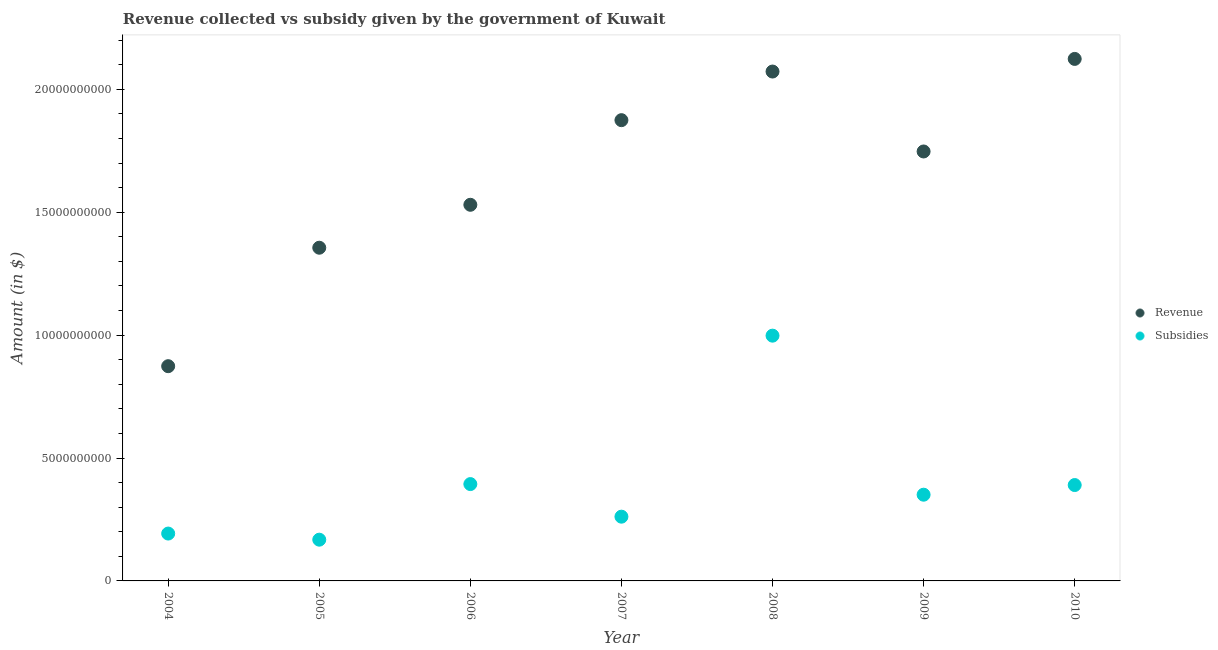What is the amount of subsidies given in 2004?
Provide a succinct answer. 1.93e+09. Across all years, what is the maximum amount of subsidies given?
Provide a short and direct response. 9.98e+09. Across all years, what is the minimum amount of subsidies given?
Your answer should be compact. 1.68e+09. In which year was the amount of revenue collected minimum?
Your response must be concise. 2004. What is the total amount of revenue collected in the graph?
Offer a very short reply. 1.16e+11. What is the difference between the amount of revenue collected in 2004 and that in 2005?
Give a very brief answer. -4.82e+09. What is the difference between the amount of revenue collected in 2007 and the amount of subsidies given in 2008?
Offer a very short reply. 8.77e+09. What is the average amount of revenue collected per year?
Provide a short and direct response. 1.65e+1. In the year 2006, what is the difference between the amount of revenue collected and amount of subsidies given?
Give a very brief answer. 1.14e+1. In how many years, is the amount of revenue collected greater than 7000000000 $?
Offer a very short reply. 7. What is the ratio of the amount of revenue collected in 2005 to that in 2008?
Offer a very short reply. 0.65. Is the amount of subsidies given in 2006 less than that in 2008?
Provide a succinct answer. Yes. What is the difference between the highest and the second highest amount of subsidies given?
Make the answer very short. 6.04e+09. What is the difference between the highest and the lowest amount of subsidies given?
Ensure brevity in your answer.  8.30e+09. In how many years, is the amount of subsidies given greater than the average amount of subsidies given taken over all years?
Provide a short and direct response. 2. How many dotlines are there?
Ensure brevity in your answer.  2. How many years are there in the graph?
Keep it short and to the point. 7. Does the graph contain any zero values?
Make the answer very short. No. How many legend labels are there?
Provide a succinct answer. 2. What is the title of the graph?
Keep it short and to the point. Revenue collected vs subsidy given by the government of Kuwait. What is the label or title of the X-axis?
Keep it short and to the point. Year. What is the label or title of the Y-axis?
Make the answer very short. Amount (in $). What is the Amount (in $) of Revenue in 2004?
Ensure brevity in your answer.  8.74e+09. What is the Amount (in $) of Subsidies in 2004?
Your response must be concise. 1.93e+09. What is the Amount (in $) of Revenue in 2005?
Make the answer very short. 1.36e+1. What is the Amount (in $) in Subsidies in 2005?
Offer a terse response. 1.68e+09. What is the Amount (in $) of Revenue in 2006?
Provide a succinct answer. 1.53e+1. What is the Amount (in $) of Subsidies in 2006?
Give a very brief answer. 3.94e+09. What is the Amount (in $) of Revenue in 2007?
Provide a succinct answer. 1.87e+1. What is the Amount (in $) in Subsidies in 2007?
Your answer should be very brief. 2.61e+09. What is the Amount (in $) in Revenue in 2008?
Your answer should be very brief. 2.07e+1. What is the Amount (in $) in Subsidies in 2008?
Offer a terse response. 9.98e+09. What is the Amount (in $) in Revenue in 2009?
Make the answer very short. 1.75e+1. What is the Amount (in $) of Subsidies in 2009?
Your response must be concise. 3.51e+09. What is the Amount (in $) in Revenue in 2010?
Provide a succinct answer. 2.12e+1. What is the Amount (in $) in Subsidies in 2010?
Offer a very short reply. 3.90e+09. Across all years, what is the maximum Amount (in $) in Revenue?
Offer a very short reply. 2.12e+1. Across all years, what is the maximum Amount (in $) in Subsidies?
Offer a terse response. 9.98e+09. Across all years, what is the minimum Amount (in $) in Revenue?
Give a very brief answer. 8.74e+09. Across all years, what is the minimum Amount (in $) in Subsidies?
Keep it short and to the point. 1.68e+09. What is the total Amount (in $) in Revenue in the graph?
Ensure brevity in your answer.  1.16e+11. What is the total Amount (in $) of Subsidies in the graph?
Give a very brief answer. 2.75e+1. What is the difference between the Amount (in $) of Revenue in 2004 and that in 2005?
Make the answer very short. -4.82e+09. What is the difference between the Amount (in $) in Subsidies in 2004 and that in 2005?
Make the answer very short. 2.49e+08. What is the difference between the Amount (in $) of Revenue in 2004 and that in 2006?
Give a very brief answer. -6.57e+09. What is the difference between the Amount (in $) in Subsidies in 2004 and that in 2006?
Your answer should be compact. -2.01e+09. What is the difference between the Amount (in $) of Revenue in 2004 and that in 2007?
Give a very brief answer. -1.00e+1. What is the difference between the Amount (in $) in Subsidies in 2004 and that in 2007?
Ensure brevity in your answer.  -6.87e+08. What is the difference between the Amount (in $) in Revenue in 2004 and that in 2008?
Provide a succinct answer. -1.20e+1. What is the difference between the Amount (in $) of Subsidies in 2004 and that in 2008?
Provide a succinct answer. -8.05e+09. What is the difference between the Amount (in $) in Revenue in 2004 and that in 2009?
Keep it short and to the point. -8.74e+09. What is the difference between the Amount (in $) of Subsidies in 2004 and that in 2009?
Ensure brevity in your answer.  -1.58e+09. What is the difference between the Amount (in $) in Revenue in 2004 and that in 2010?
Ensure brevity in your answer.  -1.25e+1. What is the difference between the Amount (in $) in Subsidies in 2004 and that in 2010?
Offer a very short reply. -1.97e+09. What is the difference between the Amount (in $) in Revenue in 2005 and that in 2006?
Provide a succinct answer. -1.75e+09. What is the difference between the Amount (in $) in Subsidies in 2005 and that in 2006?
Keep it short and to the point. -2.26e+09. What is the difference between the Amount (in $) in Revenue in 2005 and that in 2007?
Ensure brevity in your answer.  -5.19e+09. What is the difference between the Amount (in $) in Subsidies in 2005 and that in 2007?
Provide a succinct answer. -9.36e+08. What is the difference between the Amount (in $) of Revenue in 2005 and that in 2008?
Make the answer very short. -7.17e+09. What is the difference between the Amount (in $) in Subsidies in 2005 and that in 2008?
Give a very brief answer. -8.30e+09. What is the difference between the Amount (in $) in Revenue in 2005 and that in 2009?
Ensure brevity in your answer.  -3.92e+09. What is the difference between the Amount (in $) in Subsidies in 2005 and that in 2009?
Your answer should be very brief. -1.83e+09. What is the difference between the Amount (in $) in Revenue in 2005 and that in 2010?
Provide a short and direct response. -7.68e+09. What is the difference between the Amount (in $) of Subsidies in 2005 and that in 2010?
Your answer should be very brief. -2.22e+09. What is the difference between the Amount (in $) of Revenue in 2006 and that in 2007?
Your answer should be very brief. -3.44e+09. What is the difference between the Amount (in $) of Subsidies in 2006 and that in 2007?
Ensure brevity in your answer.  1.33e+09. What is the difference between the Amount (in $) of Revenue in 2006 and that in 2008?
Provide a short and direct response. -5.42e+09. What is the difference between the Amount (in $) in Subsidies in 2006 and that in 2008?
Your response must be concise. -6.04e+09. What is the difference between the Amount (in $) in Revenue in 2006 and that in 2009?
Your answer should be compact. -2.17e+09. What is the difference between the Amount (in $) of Subsidies in 2006 and that in 2009?
Provide a short and direct response. 4.32e+08. What is the difference between the Amount (in $) of Revenue in 2006 and that in 2010?
Make the answer very short. -5.94e+09. What is the difference between the Amount (in $) in Subsidies in 2006 and that in 2010?
Make the answer very short. 3.90e+07. What is the difference between the Amount (in $) in Revenue in 2007 and that in 2008?
Offer a very short reply. -1.98e+09. What is the difference between the Amount (in $) of Subsidies in 2007 and that in 2008?
Provide a succinct answer. -7.36e+09. What is the difference between the Amount (in $) of Revenue in 2007 and that in 2009?
Make the answer very short. 1.27e+09. What is the difference between the Amount (in $) in Subsidies in 2007 and that in 2009?
Your answer should be very brief. -8.94e+08. What is the difference between the Amount (in $) of Revenue in 2007 and that in 2010?
Your answer should be very brief. -2.49e+09. What is the difference between the Amount (in $) of Subsidies in 2007 and that in 2010?
Your answer should be very brief. -1.29e+09. What is the difference between the Amount (in $) in Revenue in 2008 and that in 2009?
Your answer should be very brief. 3.25e+09. What is the difference between the Amount (in $) of Subsidies in 2008 and that in 2009?
Provide a succinct answer. 6.47e+09. What is the difference between the Amount (in $) in Revenue in 2008 and that in 2010?
Your answer should be compact. -5.14e+08. What is the difference between the Amount (in $) in Subsidies in 2008 and that in 2010?
Offer a terse response. 6.08e+09. What is the difference between the Amount (in $) in Revenue in 2009 and that in 2010?
Offer a very short reply. -3.77e+09. What is the difference between the Amount (in $) of Subsidies in 2009 and that in 2010?
Provide a succinct answer. -3.93e+08. What is the difference between the Amount (in $) in Revenue in 2004 and the Amount (in $) in Subsidies in 2005?
Your answer should be compact. 7.06e+09. What is the difference between the Amount (in $) in Revenue in 2004 and the Amount (in $) in Subsidies in 2006?
Your answer should be very brief. 4.80e+09. What is the difference between the Amount (in $) of Revenue in 2004 and the Amount (in $) of Subsidies in 2007?
Your answer should be compact. 6.12e+09. What is the difference between the Amount (in $) in Revenue in 2004 and the Amount (in $) in Subsidies in 2008?
Your response must be concise. -1.24e+09. What is the difference between the Amount (in $) in Revenue in 2004 and the Amount (in $) in Subsidies in 2009?
Offer a terse response. 5.23e+09. What is the difference between the Amount (in $) of Revenue in 2004 and the Amount (in $) of Subsidies in 2010?
Keep it short and to the point. 4.84e+09. What is the difference between the Amount (in $) of Revenue in 2005 and the Amount (in $) of Subsidies in 2006?
Keep it short and to the point. 9.62e+09. What is the difference between the Amount (in $) of Revenue in 2005 and the Amount (in $) of Subsidies in 2007?
Keep it short and to the point. 1.09e+1. What is the difference between the Amount (in $) in Revenue in 2005 and the Amount (in $) in Subsidies in 2008?
Keep it short and to the point. 3.58e+09. What is the difference between the Amount (in $) in Revenue in 2005 and the Amount (in $) in Subsidies in 2009?
Make the answer very short. 1.00e+1. What is the difference between the Amount (in $) of Revenue in 2005 and the Amount (in $) of Subsidies in 2010?
Make the answer very short. 9.66e+09. What is the difference between the Amount (in $) in Revenue in 2006 and the Amount (in $) in Subsidies in 2007?
Your response must be concise. 1.27e+1. What is the difference between the Amount (in $) of Revenue in 2006 and the Amount (in $) of Subsidies in 2008?
Ensure brevity in your answer.  5.32e+09. What is the difference between the Amount (in $) in Revenue in 2006 and the Amount (in $) in Subsidies in 2009?
Your answer should be very brief. 1.18e+1. What is the difference between the Amount (in $) of Revenue in 2006 and the Amount (in $) of Subsidies in 2010?
Provide a succinct answer. 1.14e+1. What is the difference between the Amount (in $) of Revenue in 2007 and the Amount (in $) of Subsidies in 2008?
Keep it short and to the point. 8.77e+09. What is the difference between the Amount (in $) of Revenue in 2007 and the Amount (in $) of Subsidies in 2009?
Offer a very short reply. 1.52e+1. What is the difference between the Amount (in $) in Revenue in 2007 and the Amount (in $) in Subsidies in 2010?
Provide a short and direct response. 1.48e+1. What is the difference between the Amount (in $) of Revenue in 2008 and the Amount (in $) of Subsidies in 2009?
Offer a very short reply. 1.72e+1. What is the difference between the Amount (in $) in Revenue in 2008 and the Amount (in $) in Subsidies in 2010?
Give a very brief answer. 1.68e+1. What is the difference between the Amount (in $) in Revenue in 2009 and the Amount (in $) in Subsidies in 2010?
Give a very brief answer. 1.36e+1. What is the average Amount (in $) of Revenue per year?
Offer a very short reply. 1.65e+1. What is the average Amount (in $) of Subsidies per year?
Keep it short and to the point. 3.94e+09. In the year 2004, what is the difference between the Amount (in $) of Revenue and Amount (in $) of Subsidies?
Keep it short and to the point. 6.81e+09. In the year 2005, what is the difference between the Amount (in $) of Revenue and Amount (in $) of Subsidies?
Offer a very short reply. 1.19e+1. In the year 2006, what is the difference between the Amount (in $) of Revenue and Amount (in $) of Subsidies?
Give a very brief answer. 1.14e+1. In the year 2007, what is the difference between the Amount (in $) in Revenue and Amount (in $) in Subsidies?
Your answer should be very brief. 1.61e+1. In the year 2008, what is the difference between the Amount (in $) of Revenue and Amount (in $) of Subsidies?
Your answer should be very brief. 1.07e+1. In the year 2009, what is the difference between the Amount (in $) in Revenue and Amount (in $) in Subsidies?
Ensure brevity in your answer.  1.40e+1. In the year 2010, what is the difference between the Amount (in $) of Revenue and Amount (in $) of Subsidies?
Keep it short and to the point. 1.73e+1. What is the ratio of the Amount (in $) of Revenue in 2004 to that in 2005?
Keep it short and to the point. 0.64. What is the ratio of the Amount (in $) of Subsidies in 2004 to that in 2005?
Offer a terse response. 1.15. What is the ratio of the Amount (in $) of Revenue in 2004 to that in 2006?
Make the answer very short. 0.57. What is the ratio of the Amount (in $) of Subsidies in 2004 to that in 2006?
Give a very brief answer. 0.49. What is the ratio of the Amount (in $) of Revenue in 2004 to that in 2007?
Make the answer very short. 0.47. What is the ratio of the Amount (in $) of Subsidies in 2004 to that in 2007?
Your answer should be compact. 0.74. What is the ratio of the Amount (in $) of Revenue in 2004 to that in 2008?
Offer a terse response. 0.42. What is the ratio of the Amount (in $) in Subsidies in 2004 to that in 2008?
Keep it short and to the point. 0.19. What is the ratio of the Amount (in $) in Subsidies in 2004 to that in 2009?
Your answer should be very brief. 0.55. What is the ratio of the Amount (in $) in Revenue in 2004 to that in 2010?
Your answer should be compact. 0.41. What is the ratio of the Amount (in $) in Subsidies in 2004 to that in 2010?
Provide a short and direct response. 0.49. What is the ratio of the Amount (in $) of Revenue in 2005 to that in 2006?
Your response must be concise. 0.89. What is the ratio of the Amount (in $) in Subsidies in 2005 to that in 2006?
Offer a very short reply. 0.43. What is the ratio of the Amount (in $) of Revenue in 2005 to that in 2007?
Ensure brevity in your answer.  0.72. What is the ratio of the Amount (in $) in Subsidies in 2005 to that in 2007?
Offer a very short reply. 0.64. What is the ratio of the Amount (in $) in Revenue in 2005 to that in 2008?
Your response must be concise. 0.65. What is the ratio of the Amount (in $) in Subsidies in 2005 to that in 2008?
Make the answer very short. 0.17. What is the ratio of the Amount (in $) of Revenue in 2005 to that in 2009?
Provide a succinct answer. 0.78. What is the ratio of the Amount (in $) in Subsidies in 2005 to that in 2009?
Your response must be concise. 0.48. What is the ratio of the Amount (in $) of Revenue in 2005 to that in 2010?
Offer a terse response. 0.64. What is the ratio of the Amount (in $) of Subsidies in 2005 to that in 2010?
Make the answer very short. 0.43. What is the ratio of the Amount (in $) in Revenue in 2006 to that in 2007?
Keep it short and to the point. 0.82. What is the ratio of the Amount (in $) of Subsidies in 2006 to that in 2007?
Ensure brevity in your answer.  1.51. What is the ratio of the Amount (in $) in Revenue in 2006 to that in 2008?
Make the answer very short. 0.74. What is the ratio of the Amount (in $) in Subsidies in 2006 to that in 2008?
Provide a succinct answer. 0.39. What is the ratio of the Amount (in $) in Revenue in 2006 to that in 2009?
Make the answer very short. 0.88. What is the ratio of the Amount (in $) of Subsidies in 2006 to that in 2009?
Ensure brevity in your answer.  1.12. What is the ratio of the Amount (in $) in Revenue in 2006 to that in 2010?
Provide a short and direct response. 0.72. What is the ratio of the Amount (in $) in Subsidies in 2006 to that in 2010?
Ensure brevity in your answer.  1.01. What is the ratio of the Amount (in $) of Revenue in 2007 to that in 2008?
Your answer should be very brief. 0.9. What is the ratio of the Amount (in $) in Subsidies in 2007 to that in 2008?
Give a very brief answer. 0.26. What is the ratio of the Amount (in $) of Revenue in 2007 to that in 2009?
Keep it short and to the point. 1.07. What is the ratio of the Amount (in $) of Subsidies in 2007 to that in 2009?
Ensure brevity in your answer.  0.75. What is the ratio of the Amount (in $) in Revenue in 2007 to that in 2010?
Make the answer very short. 0.88. What is the ratio of the Amount (in $) of Subsidies in 2007 to that in 2010?
Your response must be concise. 0.67. What is the ratio of the Amount (in $) in Revenue in 2008 to that in 2009?
Offer a terse response. 1.19. What is the ratio of the Amount (in $) in Subsidies in 2008 to that in 2009?
Keep it short and to the point. 2.84. What is the ratio of the Amount (in $) of Revenue in 2008 to that in 2010?
Ensure brevity in your answer.  0.98. What is the ratio of the Amount (in $) of Subsidies in 2008 to that in 2010?
Offer a very short reply. 2.56. What is the ratio of the Amount (in $) in Revenue in 2009 to that in 2010?
Make the answer very short. 0.82. What is the ratio of the Amount (in $) of Subsidies in 2009 to that in 2010?
Make the answer very short. 0.9. What is the difference between the highest and the second highest Amount (in $) of Revenue?
Keep it short and to the point. 5.14e+08. What is the difference between the highest and the second highest Amount (in $) of Subsidies?
Give a very brief answer. 6.04e+09. What is the difference between the highest and the lowest Amount (in $) in Revenue?
Give a very brief answer. 1.25e+1. What is the difference between the highest and the lowest Amount (in $) in Subsidies?
Provide a short and direct response. 8.30e+09. 